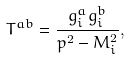Convert formula to latex. <formula><loc_0><loc_0><loc_500><loc_500>T ^ { a b } = \frac { g _ { i } ^ { a } g _ { i } ^ { b } } { p ^ { 2 } - M _ { i } ^ { 2 } } ,</formula> 